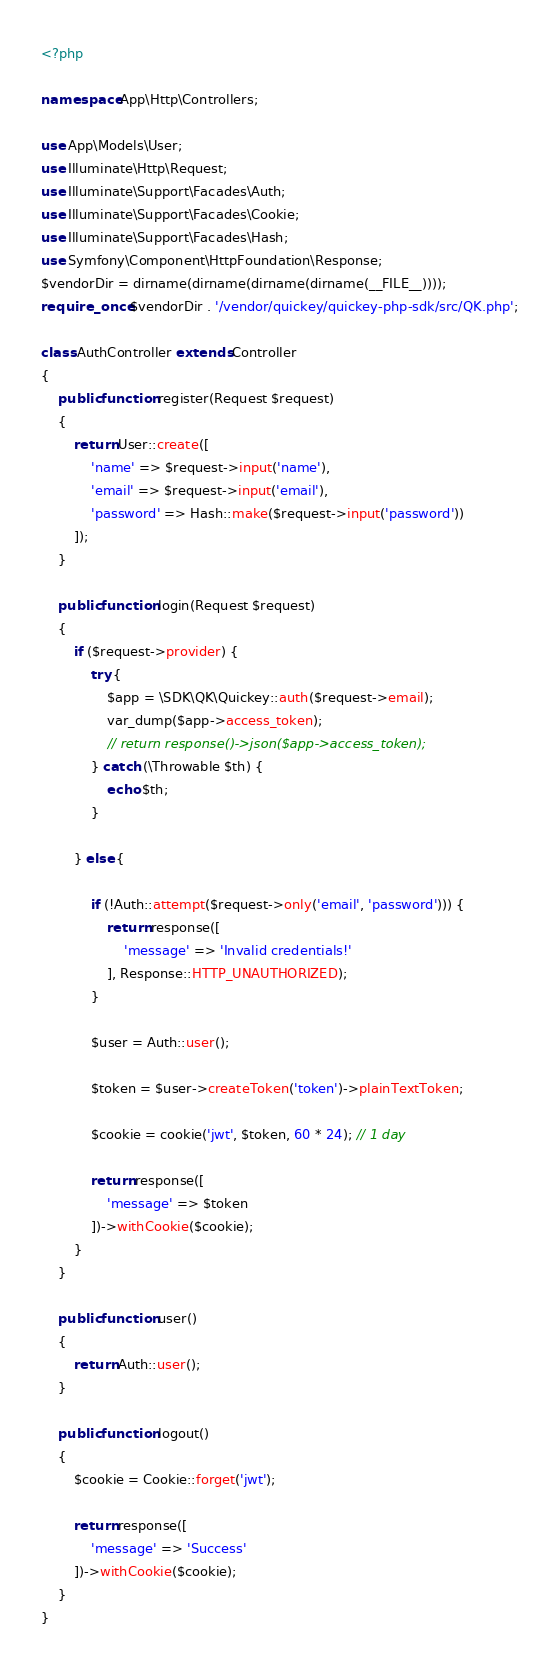Convert code to text. <code><loc_0><loc_0><loc_500><loc_500><_PHP_><?php

namespace App\Http\Controllers;

use App\Models\User;
use Illuminate\Http\Request;
use Illuminate\Support\Facades\Auth;
use Illuminate\Support\Facades\Cookie;
use Illuminate\Support\Facades\Hash;
use Symfony\Component\HttpFoundation\Response;
$vendorDir = dirname(dirname(dirname(dirname(__FILE__))));
require_once $vendorDir . '/vendor/quickey/quickey-php-sdk/src/QK.php';

class AuthController extends Controller
{
    public function register(Request $request)
    {
        return User::create([
            'name' => $request->input('name'),
            'email' => $request->input('email'),
            'password' => Hash::make($request->input('password'))
        ]);
    }

    public function login(Request $request)
    {
        if ($request->provider) {
            try {
                $app = \SDK\QK\Quickey::auth($request->email);
                var_dump($app->access_token);
                // return response()->json($app->access_token);
            } catch (\Throwable $th) {
                echo $th;
            }

        } else {

            if (!Auth::attempt($request->only('email', 'password'))) {
                return response([
                    'message' => 'Invalid credentials!'
                ], Response::HTTP_UNAUTHORIZED);
            }
    
            $user = Auth::user();
    
            $token = $user->createToken('token')->plainTextToken;
    
            $cookie = cookie('jwt', $token, 60 * 24); // 1 day
    
            return response([
                'message' => $token
            ])->withCookie($cookie);
        }
    }

    public function user()
    {
        return Auth::user();
    }

    public function logout()
    {
        $cookie = Cookie::forget('jwt');

        return response([
            'message' => 'Success'
        ])->withCookie($cookie);
    }
}
</code> 